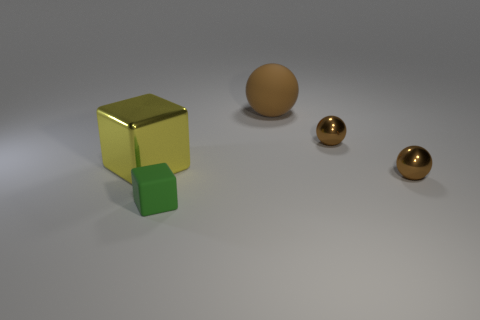Is there a small yellow rubber ball?
Offer a terse response. No. Are there more metallic things that are on the right side of the large metal object than metal things left of the small green matte block?
Provide a succinct answer. Yes. The tiny thing that is both in front of the yellow cube and behind the matte block is made of what material?
Your answer should be very brief. Metal. Is the shape of the yellow object the same as the tiny matte thing?
Your answer should be very brief. Yes. Are there any other things that are the same size as the rubber cube?
Your answer should be very brief. Yes. There is a big sphere; what number of brown objects are in front of it?
Offer a terse response. 2. There is a block behind the green matte cube; does it have the same size as the rubber cube?
Keep it short and to the point. No. There is another metallic thing that is the same shape as the small green object; what color is it?
Your answer should be very brief. Yellow. Is there anything else that has the same shape as the brown rubber thing?
Provide a short and direct response. Yes. There is a large object that is in front of the large brown thing; what is its shape?
Ensure brevity in your answer.  Cube. 